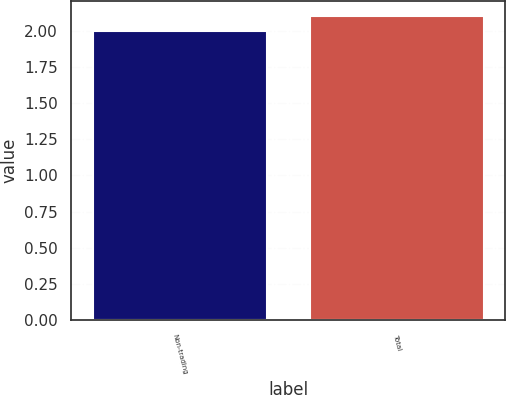Convert chart to OTSL. <chart><loc_0><loc_0><loc_500><loc_500><bar_chart><fcel>Non-trading<fcel>Total<nl><fcel>2<fcel>2.1<nl></chart> 